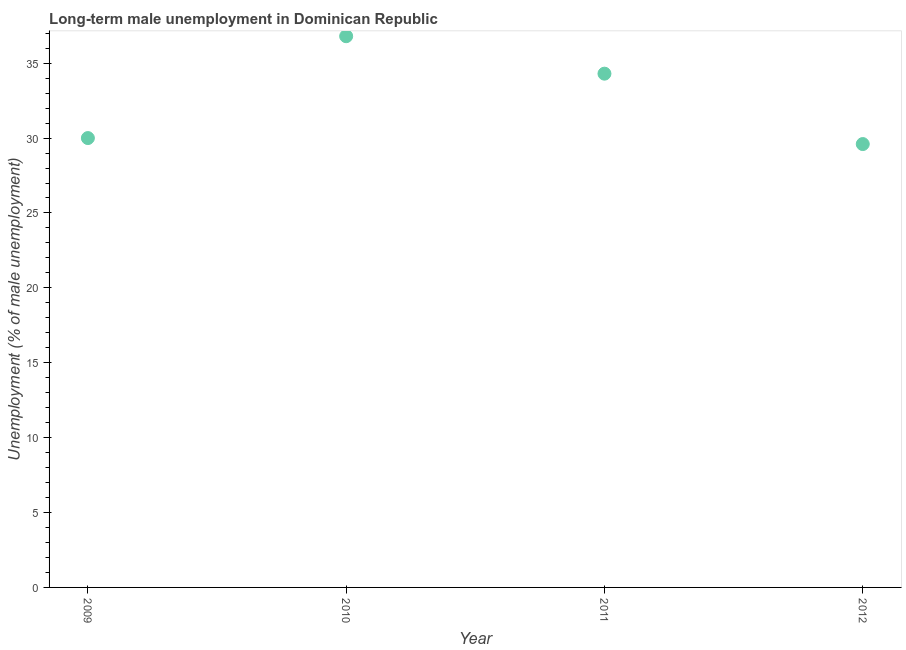What is the long-term male unemployment in 2011?
Provide a short and direct response. 34.3. Across all years, what is the maximum long-term male unemployment?
Your response must be concise. 36.8. Across all years, what is the minimum long-term male unemployment?
Make the answer very short. 29.6. In which year was the long-term male unemployment minimum?
Keep it short and to the point. 2012. What is the sum of the long-term male unemployment?
Make the answer very short. 130.7. What is the difference between the long-term male unemployment in 2011 and 2012?
Offer a very short reply. 4.7. What is the average long-term male unemployment per year?
Your answer should be very brief. 32.67. What is the median long-term male unemployment?
Offer a very short reply. 32.15. What is the ratio of the long-term male unemployment in 2010 to that in 2011?
Make the answer very short. 1.07. Is the difference between the long-term male unemployment in 2011 and 2012 greater than the difference between any two years?
Provide a short and direct response. No. Is the sum of the long-term male unemployment in 2010 and 2011 greater than the maximum long-term male unemployment across all years?
Make the answer very short. Yes. What is the difference between the highest and the lowest long-term male unemployment?
Provide a succinct answer. 7.2. Does the long-term male unemployment monotonically increase over the years?
Ensure brevity in your answer.  No. What is the title of the graph?
Your response must be concise. Long-term male unemployment in Dominican Republic. What is the label or title of the Y-axis?
Ensure brevity in your answer.  Unemployment (% of male unemployment). What is the Unemployment (% of male unemployment) in 2010?
Provide a short and direct response. 36.8. What is the Unemployment (% of male unemployment) in 2011?
Provide a succinct answer. 34.3. What is the Unemployment (% of male unemployment) in 2012?
Offer a terse response. 29.6. What is the difference between the Unemployment (% of male unemployment) in 2009 and 2011?
Provide a succinct answer. -4.3. What is the difference between the Unemployment (% of male unemployment) in 2011 and 2012?
Provide a short and direct response. 4.7. What is the ratio of the Unemployment (% of male unemployment) in 2009 to that in 2010?
Offer a very short reply. 0.81. What is the ratio of the Unemployment (% of male unemployment) in 2009 to that in 2011?
Give a very brief answer. 0.88. What is the ratio of the Unemployment (% of male unemployment) in 2010 to that in 2011?
Make the answer very short. 1.07. What is the ratio of the Unemployment (% of male unemployment) in 2010 to that in 2012?
Offer a terse response. 1.24. What is the ratio of the Unemployment (% of male unemployment) in 2011 to that in 2012?
Offer a very short reply. 1.16. 